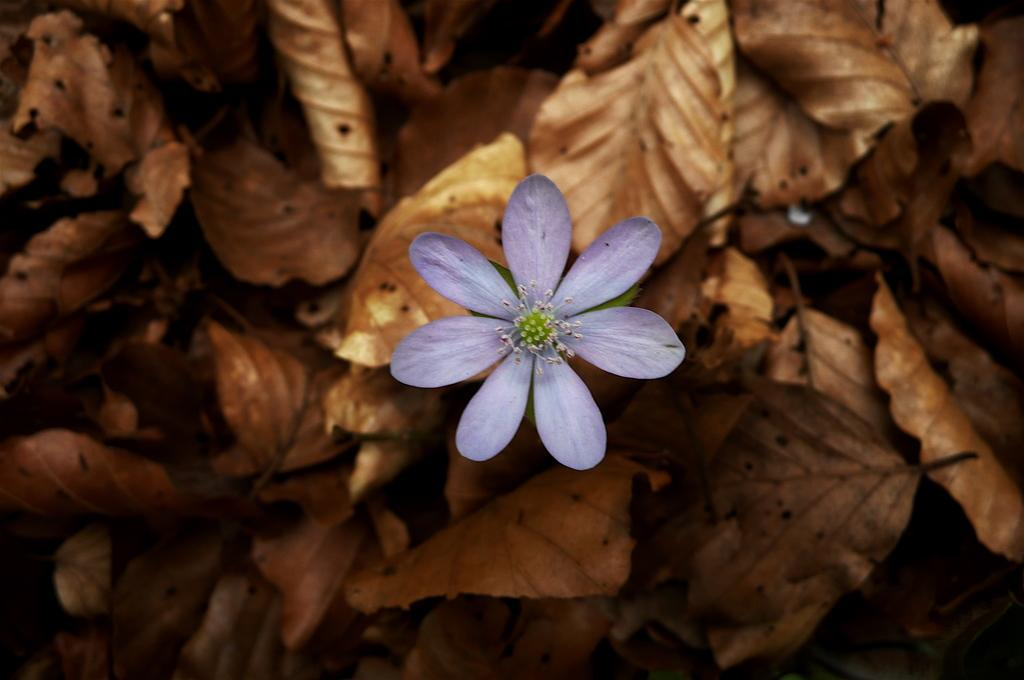What is the main subject of the image? There is a flower in the image. What can be seen in the background of the image? There are dried leaves in the background of the image. How many books are stacked on the veil in the image? There are no books or veils present in the image; it only features a flower and dried leaves. 